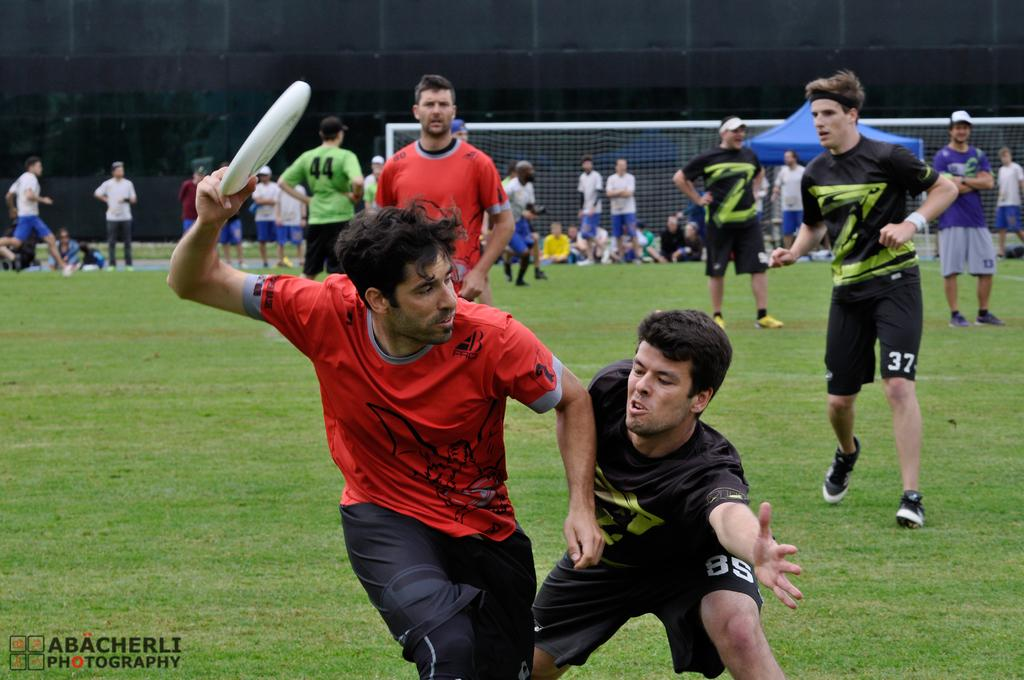What is happening on the ground in the image? There are people doing different activities on the ground in the image. What can be seen in the background of the image? There is a tent in the background. Are there any people near the tent? Yes, there are people sitting near the tent. Where is the text located in the image? The text is on the bottom left of the image. How many houses are visible in the image? There are no houses visible in the image; it features a tent in the background. What type of relationship do the sisters have in the image? There are no sisters present in the image. 